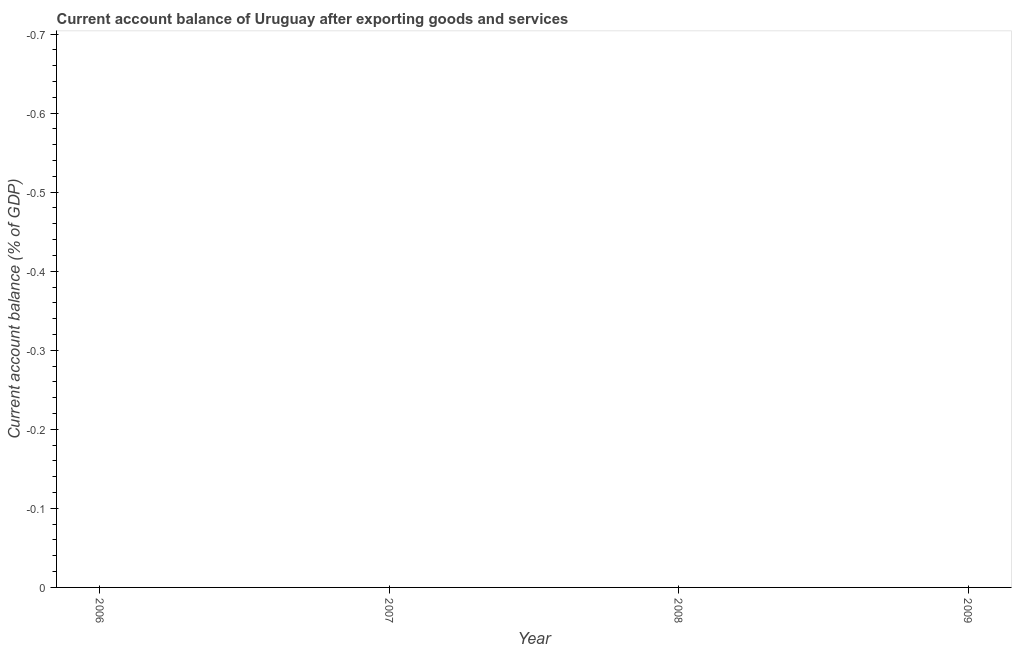Across all years, what is the minimum current account balance?
Give a very brief answer. 0. What is the average current account balance per year?
Give a very brief answer. 0. What is the median current account balance?
Your response must be concise. 0. In how many years, is the current account balance greater than -0.68 %?
Offer a terse response. 0. In how many years, is the current account balance greater than the average current account balance taken over all years?
Provide a short and direct response. 0. How many dotlines are there?
Your answer should be very brief. 0. What is the difference between two consecutive major ticks on the Y-axis?
Your response must be concise. 0.1. Are the values on the major ticks of Y-axis written in scientific E-notation?
Your answer should be very brief. No. What is the title of the graph?
Your response must be concise. Current account balance of Uruguay after exporting goods and services. What is the label or title of the X-axis?
Make the answer very short. Year. What is the label or title of the Y-axis?
Your answer should be compact. Current account balance (% of GDP). What is the Current account balance (% of GDP) in 2006?
Your response must be concise. 0. What is the Current account balance (% of GDP) in 2009?
Ensure brevity in your answer.  0. 